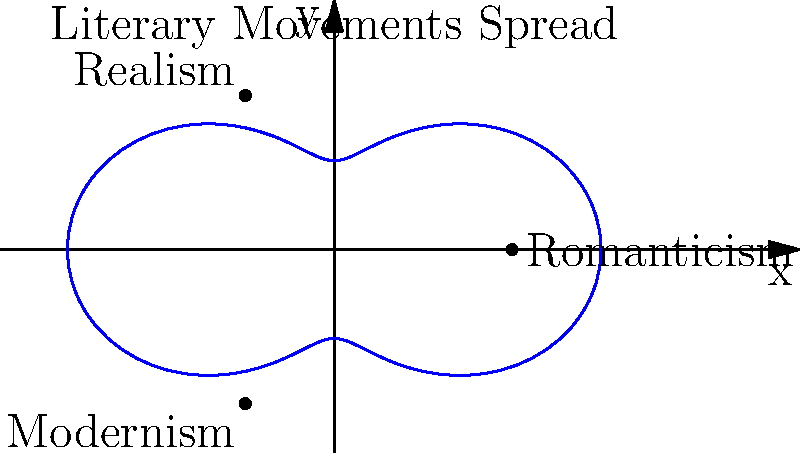In the polar coordinate representation of literary movements' spread, Romanticism is positioned at $(2,0)$, Realism at $(-1,\sqrt{3})$, and Modernism at $(-1,-\sqrt{3})$. If the equation of the curve is $r = 2 + \cos(2\theta)$, at which angle $\theta$ (in radians) does the spread of Modernism reach its maximum distance from the origin? To find the angle $\theta$ where Modernism reaches its maximum distance:

1) The equation is $r = 2 + \cos(2\theta)$
2) Maximum $r$ occurs when $\cos(2\theta) = 1$
3) This happens when $2\theta = 2\pi n$, where $n$ is an integer
4) Solving for $\theta$: $\theta = \pi n$
5) In the third quadrant (where Modernism is), $n = 1$
6) Therefore, the maximum occurs at $\theta = \pi$ radians

We can verify:
- At $\theta = \pi$, $r = 2 + \cos(2\pi) = 2 + 1 = 3$
- This is indeed the maximum distance from the origin in the third quadrant
Answer: $\pi$ radians 